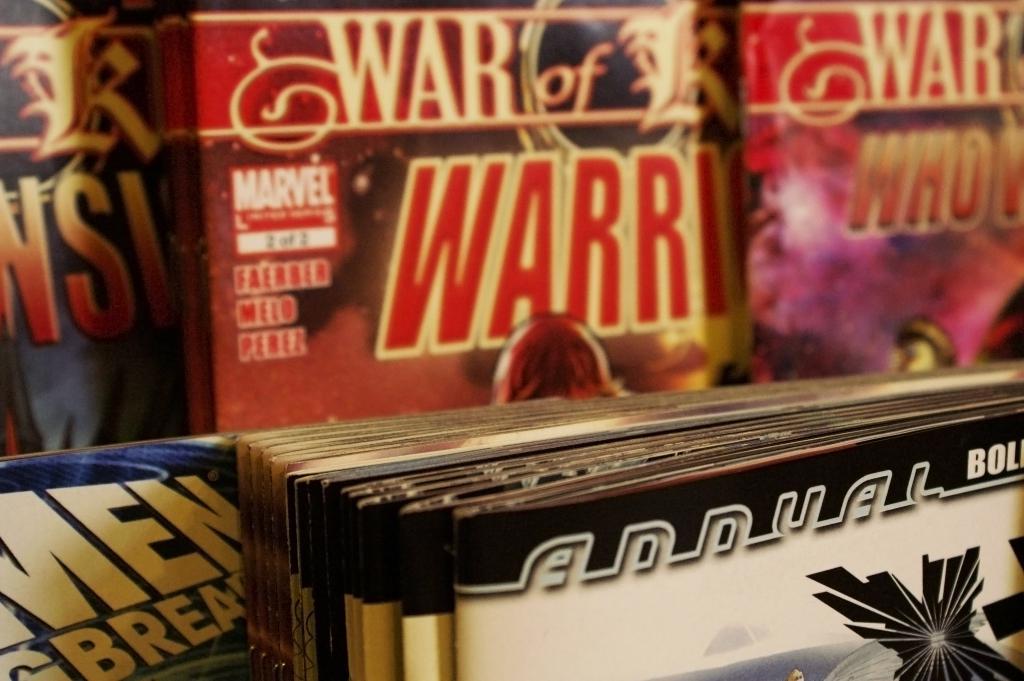What is the first word on the magazine in the center top of the image?
Offer a terse response. War. Is that comic a marvel comic?
Offer a very short reply. Yes. 